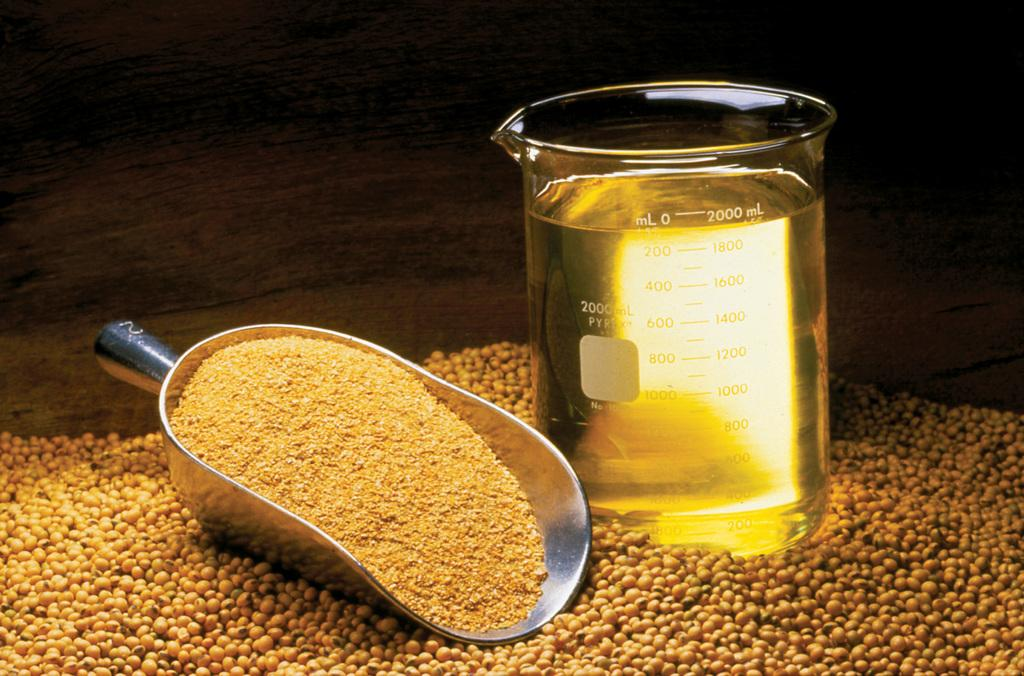<image>
Provide a brief description of the given image. A scooper is next to a measuring glass that is 2000 ml full of liquid. 